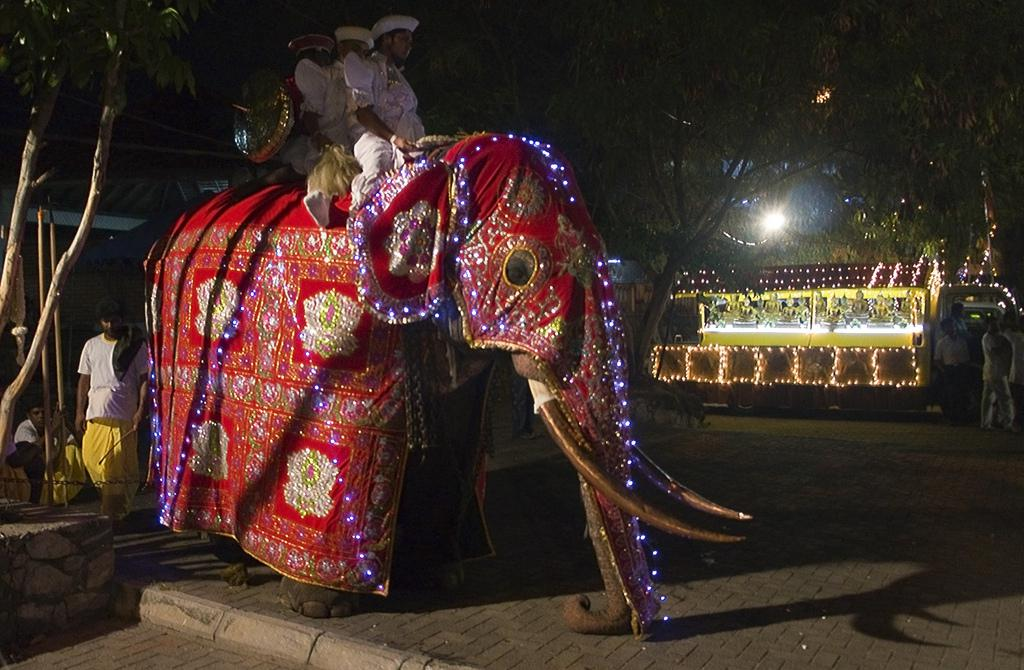Question: what is this picture of?
Choices:
A. A tiger.
B. A dog.
C. A lion.
D. An elephant.
Answer with the letter. Answer: D Question: what has long tusks?
Choices:
A. The walrus.
B. The narwhal.
C. The unicorn.
D. The elephant.
Answer with the letter. Answer: D Question: what color caps are the men riding the elephant wearing?
Choices:
A. Red.
B. Yellow.
C. White.
D. Green.
Answer with the letter. Answer: C Question: what can be seen through the hole in the elephant's costume?
Choices:
A. The elephants nose.
B. The elephants ears.
C. The elephant's eye.
D. The elephants tail.
Answer with the letter. Answer: C Question: what are the people doing?
Choices:
A. Rising in a car.
B. Riding the elephant.
C. Dancing.
D. Walking.
Answer with the letter. Answer: B Question: what does the elephant have on it?
Choices:
A. Roses.
B. Bells.
C. Lights.
D. Glitter.
Answer with the letter. Answer: C Question: what has lights on it?
Choices:
A. The stands.
B. The elephant.
C. The christmas tree.
D. The house.
Answer with the letter. Answer: B Question: what time of day is it?
Choices:
A. Daytime.
B. Night time.
C. Evening.
D. Morning.
Answer with the letter. Answer: B Question: what does it look like outside?
Choices:
A. Sunny.
B. Bright.
C. Dark.
D. Cold.
Answer with the letter. Answer: C Question: what are the people riding?
Choices:
A. A decorated elephant.
B. A horse.
C. A camel.
D. A giraffe.
Answer with the letter. Answer: A Question: how many people are riding the decorated elephant?
Choices:
A. Three.
B. Two people.
C. One.
D. Four.
Answer with the letter. Answer: B Question: what is the elephant decorated with?
Choices:
A. Red robes.
B. Tassles.
C. A mask.
D. Ribbons.
Answer with the letter. Answer: A Question: what are the red robes decorating?
Choices:
A. The trainer.
B. The assistant.
C. The circus workers.
D. The elephant.
Answer with the letter. Answer: D Question: what color are the lights on the elephant's costume?
Choices:
A. Red.
B. Purple.
C. Yellow.
D. White.
Answer with the letter. Answer: B Question: what is on the elephant's costume?
Choices:
A. Stars.
B. Gold trimming.
C. Purple lights.
D. Velvet.
Answer with the letter. Answer: C Question: where is the elephant standing?
Choices:
A. In the middle of the circus tent.
B. In the water.
C. On a brick walkway.
D. On the stage.
Answer with the letter. Answer: C Question: how many people ride the elephant?
Choices:
A. Four.
B. One.
C. Three people.
D. Two.
Answer with the letter. Answer: C Question: what are the three people doing?
Choices:
A. Swinging on the trapeze.
B. Following the animals.
C. Dancing.
D. Riding the elephant.
Answer with the letter. Answer: D Question: what are some people wearing?
Choices:
A. Raincoats.
B. Shoes.
C. Yellow pants.
D. Pants.
Answer with the letter. Answer: C Question: what are the people doing?
Choices:
A. Preparing animals for a show.
B. Studying.
C. Playing.
D. Dancing.
Answer with the letter. Answer: A Question: what are the people preparing animals for?
Choices:
A. A show.
B. Cooking.
C. Feeding.
D. Playing.
Answer with the letter. Answer: A Question: what is the animal adorned with?
Choices:
A. Lights.
B. Jewels.
C. Clothes.
D. Velvet.
Answer with the letter. Answer: A Question: what are the lights used for?
Choices:
A. Adorning the animal.
B. Photoshoot.
C. Play.
D. Show.
Answer with the letter. Answer: A Question: what is wearing an elaborate costume?
Choices:
A. A actress.
B. A actor.
C. An elephant.
D. A monkey.
Answer with the letter. Answer: C Question: when is the parade?
Choices:
A. At night.
B. In the morning.
C. In the daytime.
D. In the evening.
Answer with the letter. Answer: A Question: what is the color of the elephant's dress?
Choices:
A. Blue.
B. Purple.
C. Red.
D. White.
Answer with the letter. Answer: C Question: how is he not falling off the elephant?
Choices:
A. He is sitting on a saddle.
B. He is squeezing with his legs.
C. He is attached by a belt.
D. He is holding on.
Answer with the letter. Answer: D Question: who is riding the elephant?
Choices:
A. A little boy.
B. A woman.
C. A sultan.
D. An old man.
Answer with the letter. Answer: C 